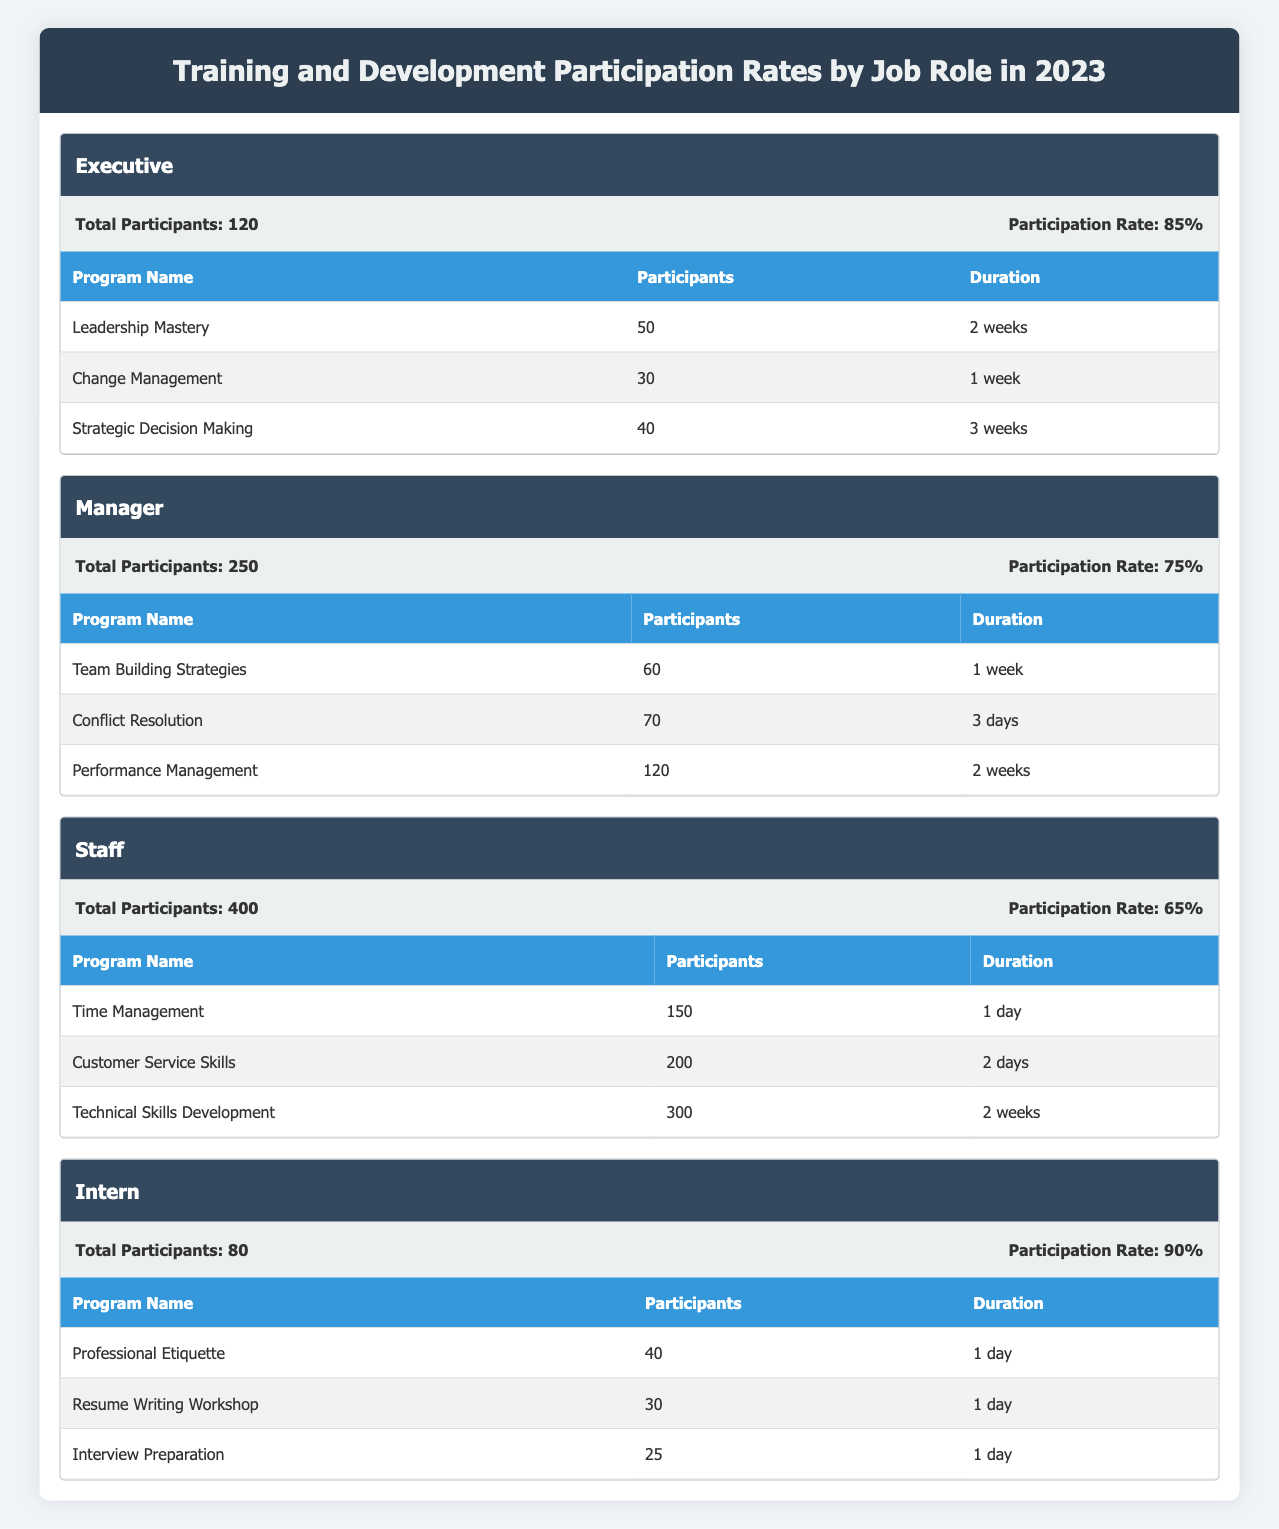What's the participation rate for Managers? The participation rate for Managers is listed directly in the table under the Manager section, which states "Participation Rate: 75%".
Answer: 75% How many total participants were involved in Technical Skills Development? Technical Skills Development has 300 participants listed in the Staff section, as shown in the programs table under Staff.
Answer: 300 Which job role had the highest participation rate? Comparing the participation rates from the table, Executives had a rate of 85%, Managers had 75%, Staff had 65%, and Interns had 90%. Since 90% is the highest rate, Interns had the highest participation rate.
Answer: Intern What is the total number of participants across all job roles? To find the total, sum the total participants for each job role: 120 (Executive) + 250 (Manager) + 400 (Staff) + 80 (Intern) = 850.
Answer: 850 Did more Staff or Interns participate in Time Management training? Staff had 150 participants in Time Management, while Interns did not participate in this program at all. Thus, Staff had more participants.
Answer: Yes Which program had the most participants among all job roles? Checking the participants in all programs shows Technical Skills Development had 300 participants under the Staff role, which is the highest compared to other programs.
Answer: Technical Skills Development What is the average participation rate for all job roles? The participation rates are 85% (Executive), 75% (Manager), 65% (Staff), and 90% (Intern). To find the average, add them (85 + 75 + 65 + 90 = 315) and divide by the number of job roles (4): 315 / 4 = 78.75%.
Answer: 78.75% Which training programs did Interns participate in? The programs listed for Interns include "Professional Etiquette", "Resume Writing Workshop", and "Interview Preparation". The number of participants for each is also shown: 40, 30, and 25 respectively.
Answer: Professional Etiquette, Resume Writing Workshop, Interview Preparation What is the difference in total participants between Staff and Executives? To find the difference, subtract the total participants for Executives (120) from the total for Staff (400): 400 - 120 = 280.
Answer: 280 